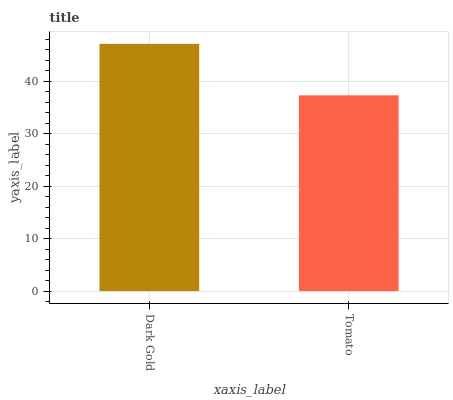Is Tomato the maximum?
Answer yes or no. No. Is Dark Gold greater than Tomato?
Answer yes or no. Yes. Is Tomato less than Dark Gold?
Answer yes or no. Yes. Is Tomato greater than Dark Gold?
Answer yes or no. No. Is Dark Gold less than Tomato?
Answer yes or no. No. Is Dark Gold the high median?
Answer yes or no. Yes. Is Tomato the low median?
Answer yes or no. Yes. Is Tomato the high median?
Answer yes or no. No. Is Dark Gold the low median?
Answer yes or no. No. 